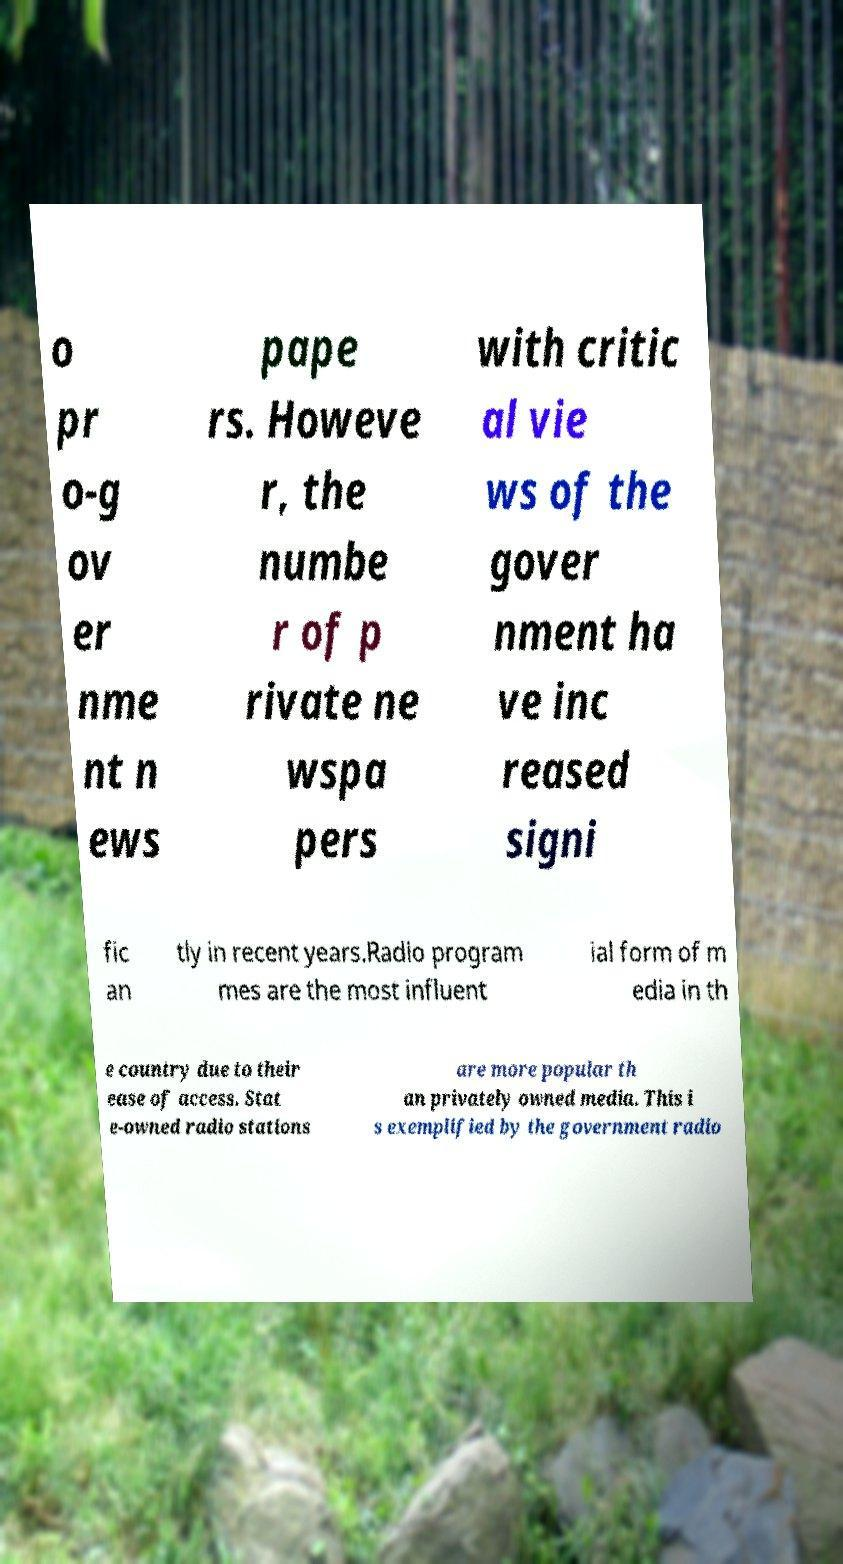For documentation purposes, I need the text within this image transcribed. Could you provide that? o pr o-g ov er nme nt n ews pape rs. Howeve r, the numbe r of p rivate ne wspa pers with critic al vie ws of the gover nment ha ve inc reased signi fic an tly in recent years.Radio program mes are the most influent ial form of m edia in th e country due to their ease of access. Stat e-owned radio stations are more popular th an privately owned media. This i s exemplified by the government radio 